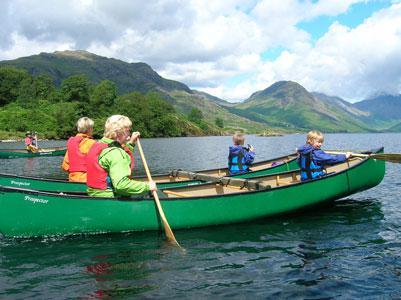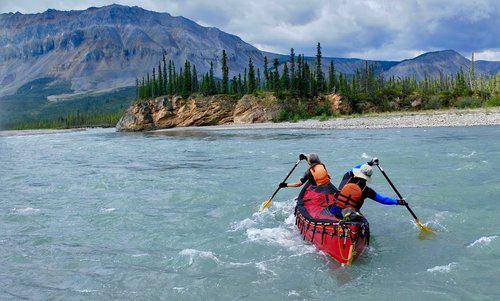The first image is the image on the left, the second image is the image on the right. Assess this claim about the two images: "Two green canoes are parallel to each other on the water, in the right image.". Correct or not? Answer yes or no. No. The first image is the image on the left, the second image is the image on the right. Evaluate the accuracy of this statement regarding the images: "One of the images features a single canoe.". Is it true? Answer yes or no. Yes. 